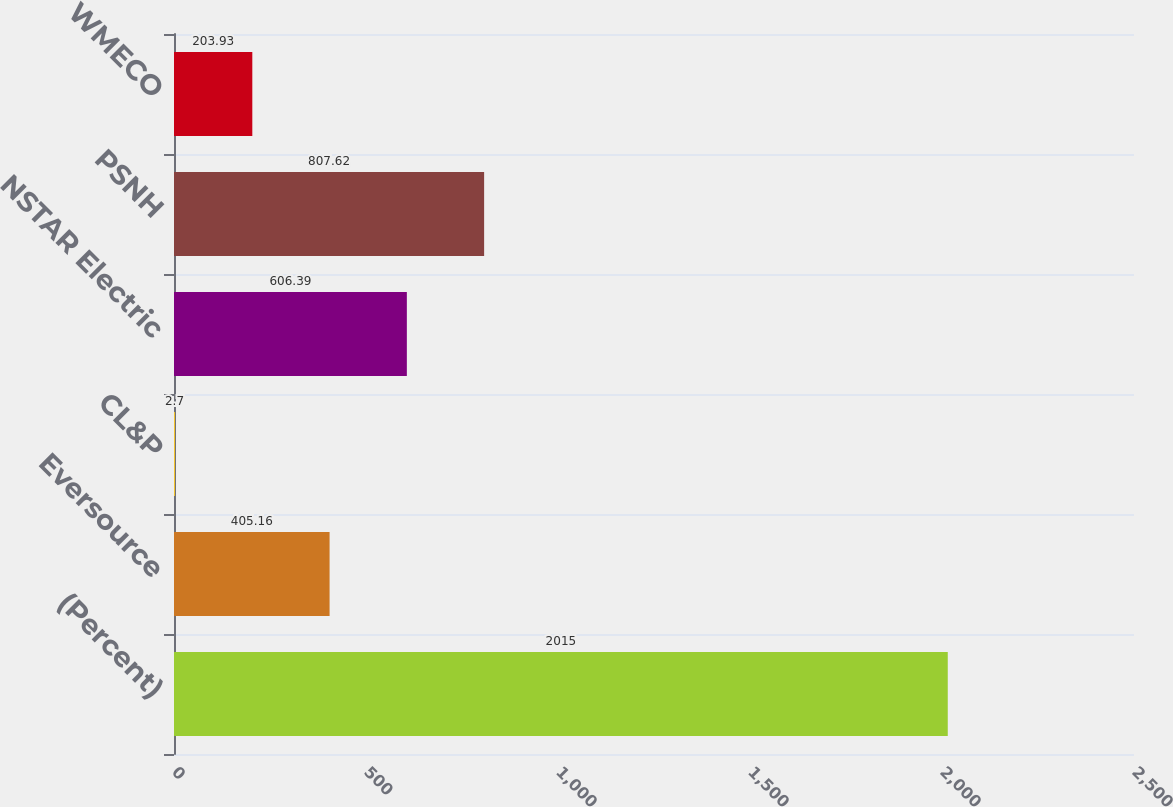Convert chart. <chart><loc_0><loc_0><loc_500><loc_500><bar_chart><fcel>(Percent)<fcel>Eversource<fcel>CL&P<fcel>NSTAR Electric<fcel>PSNH<fcel>WMECO<nl><fcel>2015<fcel>405.16<fcel>2.7<fcel>606.39<fcel>807.62<fcel>203.93<nl></chart> 